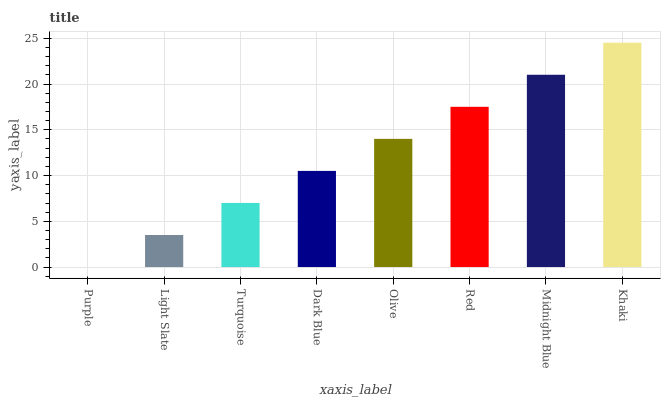Is Purple the minimum?
Answer yes or no. Yes. Is Khaki the maximum?
Answer yes or no. Yes. Is Light Slate the minimum?
Answer yes or no. No. Is Light Slate the maximum?
Answer yes or no. No. Is Light Slate greater than Purple?
Answer yes or no. Yes. Is Purple less than Light Slate?
Answer yes or no. Yes. Is Purple greater than Light Slate?
Answer yes or no. No. Is Light Slate less than Purple?
Answer yes or no. No. Is Olive the high median?
Answer yes or no. Yes. Is Dark Blue the low median?
Answer yes or no. Yes. Is Purple the high median?
Answer yes or no. No. Is Olive the low median?
Answer yes or no. No. 